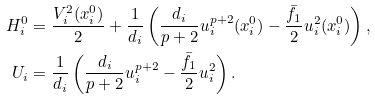<formula> <loc_0><loc_0><loc_500><loc_500>H _ { i } ^ { 0 } & = \frac { V _ { i } ^ { 2 } ( x _ { i } ^ { 0 } ) } { 2 } + \frac { 1 } { d _ { i } } \left ( \frac { d _ { i } } { p + 2 } u _ { i } ^ { p + 2 } ( x _ { i } ^ { 0 } ) - \frac { \bar { f } _ { 1 } } { 2 } u _ { i } ^ { 2 } ( x _ { i } ^ { 0 } ) \right ) , \\ U _ { i } & = \frac { 1 } { d _ { i } } \left ( \frac { d _ { i } } { p + 2 } u _ { i } ^ { p + 2 } - \frac { \bar { f } _ { 1 } } { 2 } u _ { i } ^ { 2 } \right ) .</formula> 